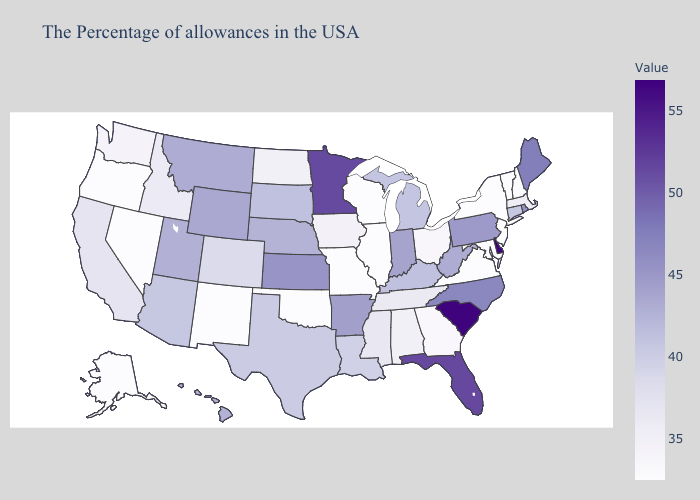Among the states that border California , does Nevada have the highest value?
Give a very brief answer. No. Does Virginia have the highest value in the South?
Concise answer only. No. Which states hav the highest value in the Northeast?
Answer briefly. Maine. Which states have the highest value in the USA?
Quick response, please. Delaware. Does Louisiana have a lower value than Arkansas?
Short answer required. Yes. Among the states that border South Carolina , which have the highest value?
Answer briefly. North Carolina. Does Alaska have the highest value in the West?
Concise answer only. No. 